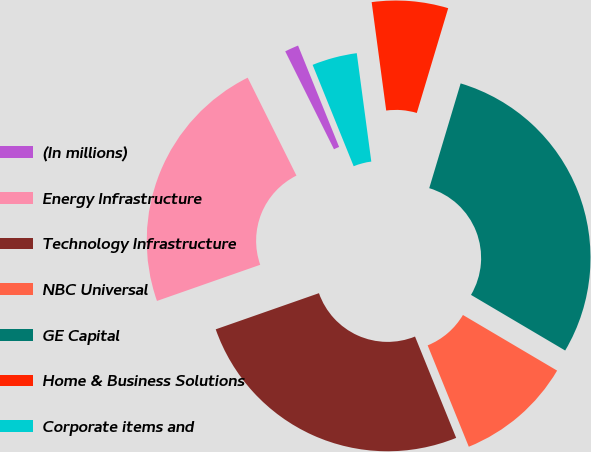Convert chart to OTSL. <chart><loc_0><loc_0><loc_500><loc_500><pie_chart><fcel>(In millions)<fcel>Energy Infrastructure<fcel>Technology Infrastructure<fcel>NBC Universal<fcel>GE Capital<fcel>Home & Business Solutions<fcel>Corporate items and<nl><fcel>1.23%<fcel>23.01%<fcel>25.78%<fcel>10.37%<fcel>28.86%<fcel>6.76%<fcel>4.0%<nl></chart> 